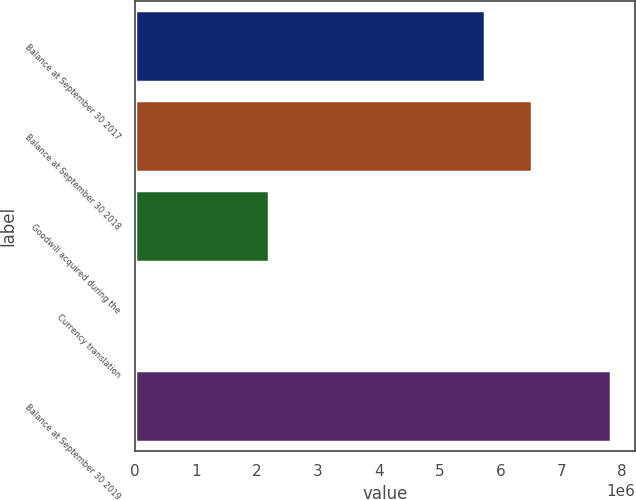Convert chart. <chart><loc_0><loc_0><loc_500><loc_500><bar_chart><fcel>Balance at September 30 2017<fcel>Balance at September 30 2018<fcel>Goodwill acquired during the<fcel>Currency translation<fcel>Balance at September 30 2019<nl><fcel>5.74534e+06<fcel>6.52306e+06<fcel>2.19432e+06<fcel>42930<fcel>7.8201e+06<nl></chart> 